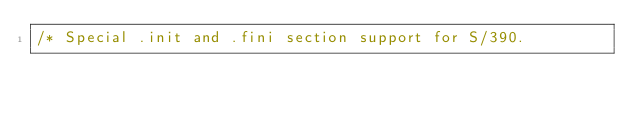<code> <loc_0><loc_0><loc_500><loc_500><_C_>/* Special .init and .fini section support for S/390.</code> 